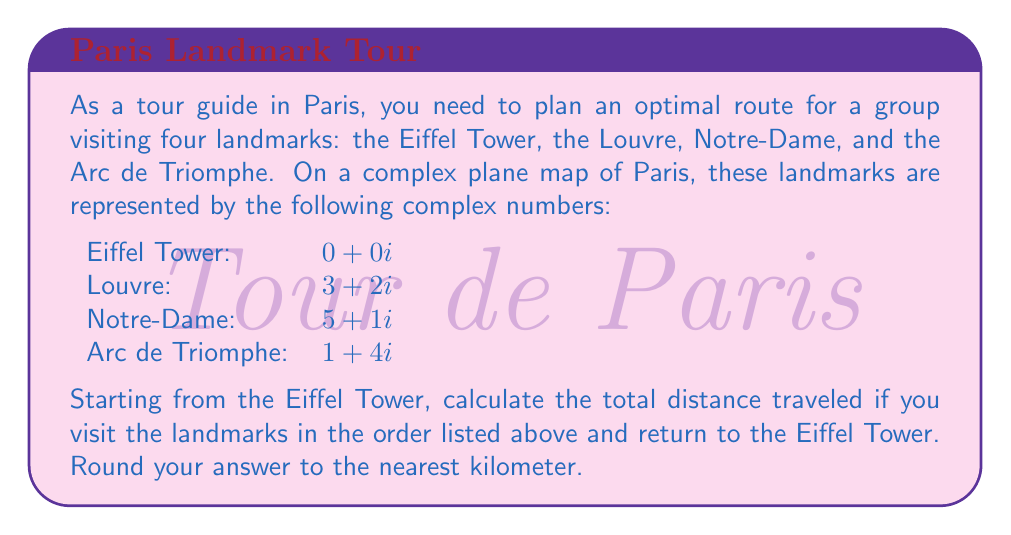Help me with this question. Let's approach this step-by-step:

1) First, we need to calculate the distances between each pair of consecutive landmarks. We can do this by finding the absolute value (magnitude) of the difference between their complex representations.

2) Eiffel Tower to Louvre:
   $|3 + 2i - (0 + 0i)| = |3 + 2i| = \sqrt{3^2 + 2^2} = \sqrt{13} \approx 3.61$ km

3) Louvre to Notre-Dame:
   $|(5 + 1i) - (3 + 2i)| = |2 - i| = \sqrt{2^2 + (-1)^2} = \sqrt{5} \approx 2.24$ km

4) Notre-Dame to Arc de Triomphe:
   $|(1 + 4i) - (5 + 1i)| = |-4 + 3i| = \sqrt{(-4)^2 + 3^2} = \sqrt{25} = 5$ km

5) Arc de Triomphe back to Eiffel Tower:
   $|(0 + 0i) - (1 + 4i)| = |-1 - 4i| = \sqrt{(-1)^2 + (-4)^2} = \sqrt{17} \approx 4.12$ km

6) Now, we sum up all these distances:
   Total distance = $\sqrt{13} + \sqrt{5} + 5 + \sqrt{17} \approx 3.61 + 2.24 + 5 + 4.12 = 14.97$ km

7) Rounding to the nearest kilometer, we get 15 km.
Answer: 15 km 